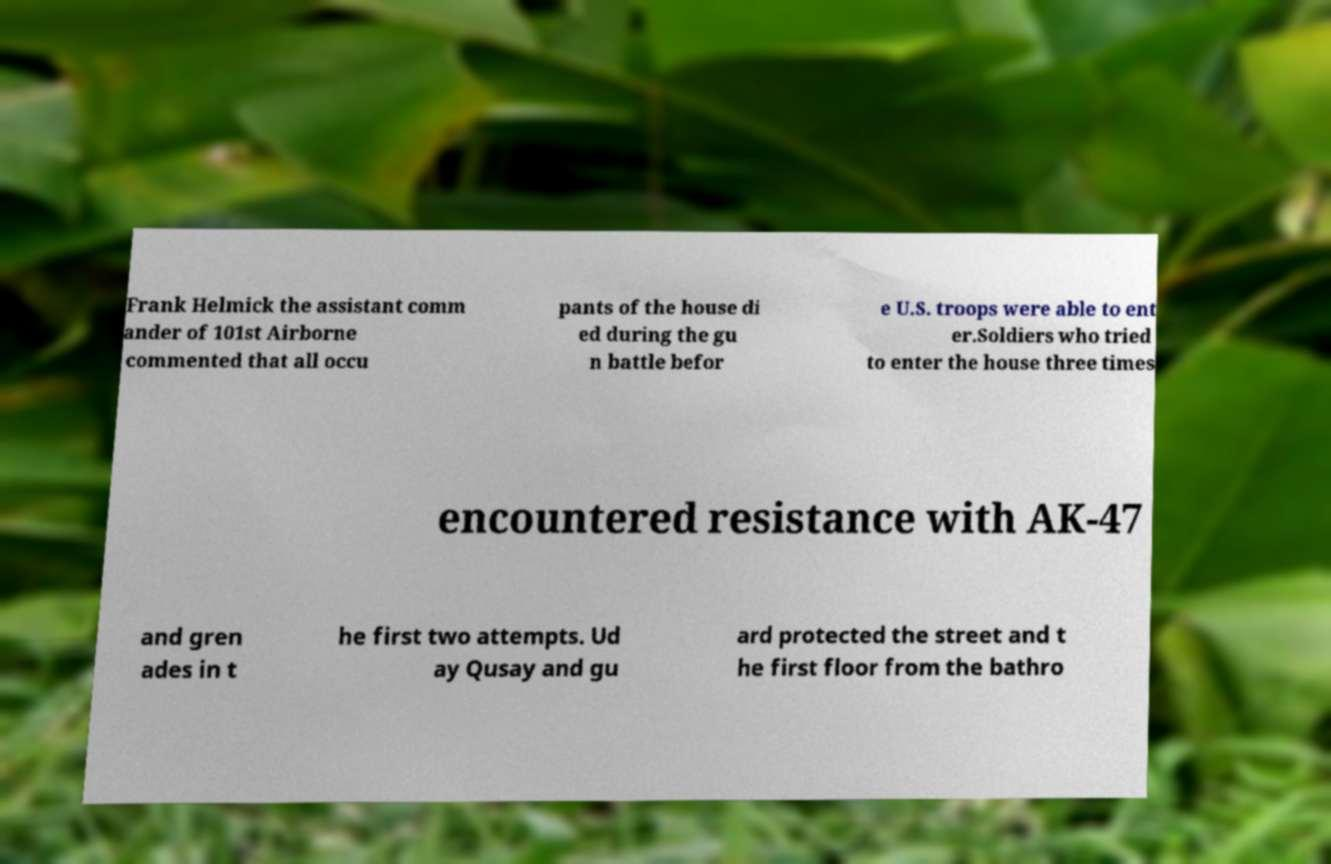Can you read and provide the text displayed in the image?This photo seems to have some interesting text. Can you extract and type it out for me? Frank Helmick the assistant comm ander of 101st Airborne commented that all occu pants of the house di ed during the gu n battle befor e U.S. troops were able to ent er.Soldiers who tried to enter the house three times encountered resistance with AK-47 and gren ades in t he first two attempts. Ud ay Qusay and gu ard protected the street and t he first floor from the bathro 